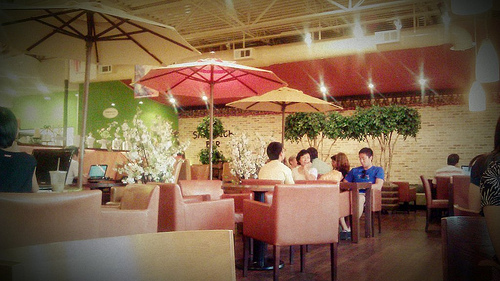How many people are wearing a blue shirt? In the image, there is one person wearing a blue shirt who is seated at the table with three other individuals. 